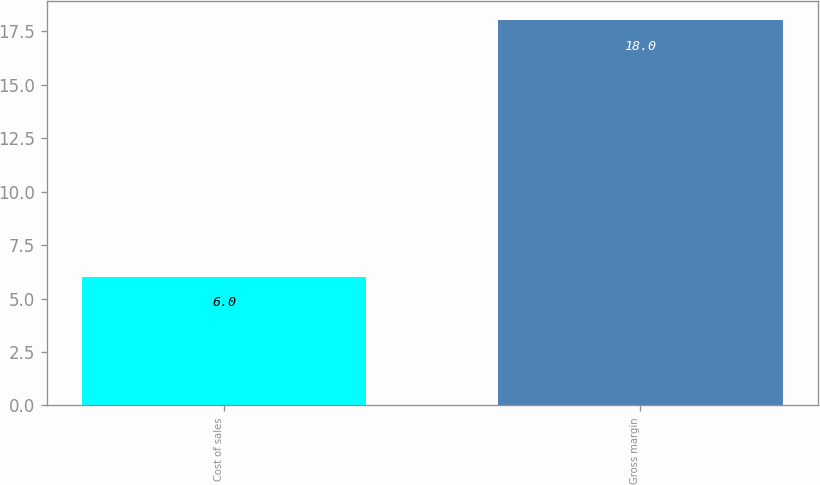Convert chart. <chart><loc_0><loc_0><loc_500><loc_500><bar_chart><fcel>Cost of sales<fcel>Gross margin<nl><fcel>6<fcel>18<nl></chart> 